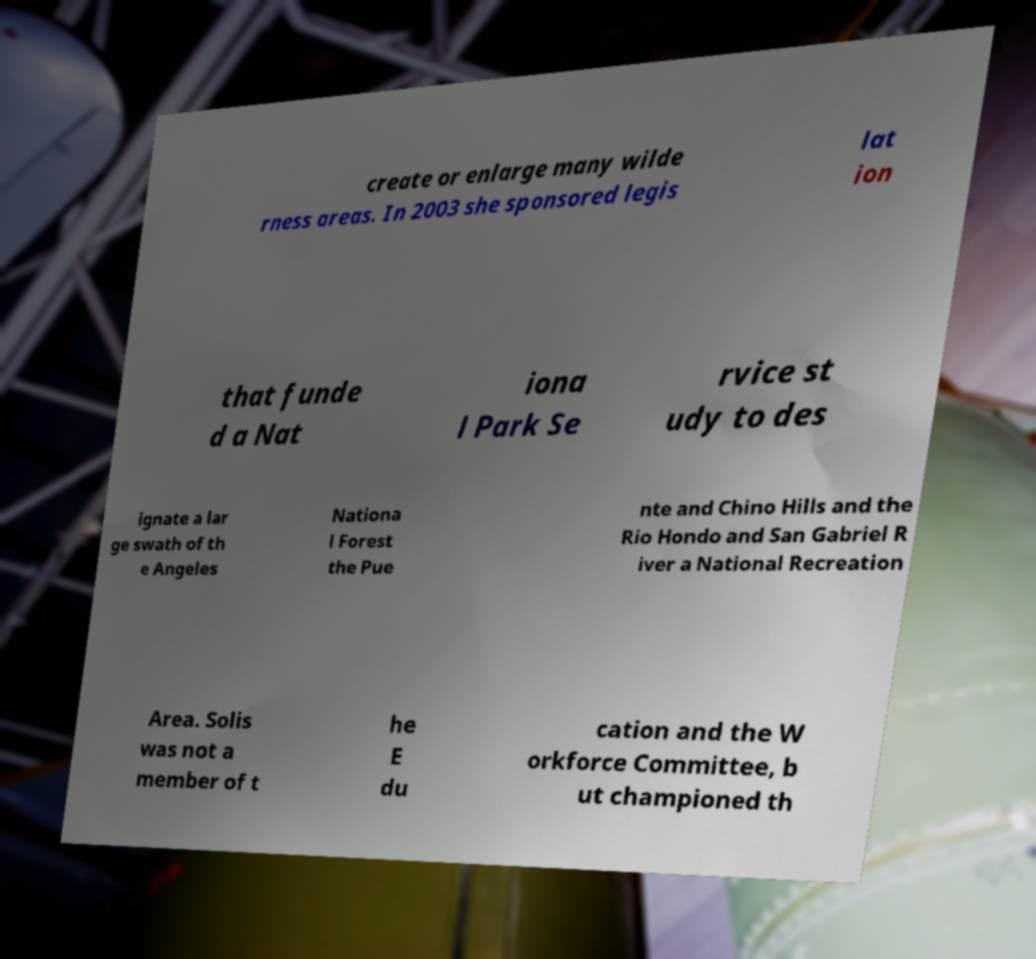Please read and relay the text visible in this image. What does it say? create or enlarge many wilde rness areas. In 2003 she sponsored legis lat ion that funde d a Nat iona l Park Se rvice st udy to des ignate a lar ge swath of th e Angeles Nationa l Forest the Pue nte and Chino Hills and the Rio Hondo and San Gabriel R iver a National Recreation Area. Solis was not a member of t he E du cation and the W orkforce Committee, b ut championed th 